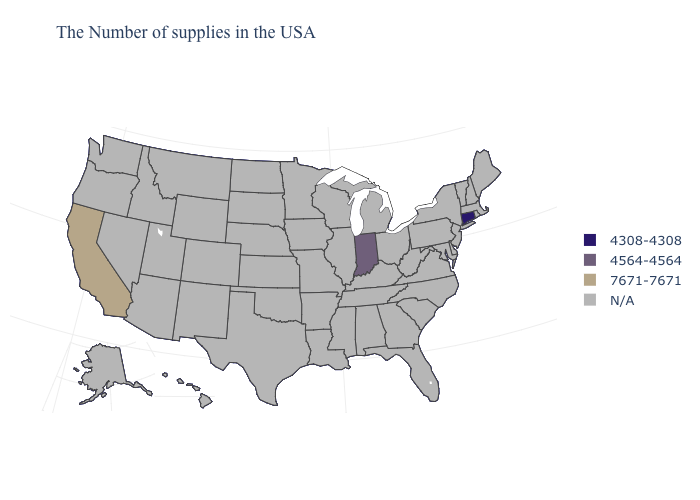Is the legend a continuous bar?
Answer briefly. No. Among the states that border Nevada , which have the lowest value?
Short answer required. California. Name the states that have a value in the range N/A?
Concise answer only. Maine, Massachusetts, Rhode Island, New Hampshire, Vermont, New York, New Jersey, Delaware, Maryland, Pennsylvania, Virginia, North Carolina, South Carolina, West Virginia, Ohio, Florida, Georgia, Michigan, Kentucky, Alabama, Tennessee, Wisconsin, Illinois, Mississippi, Louisiana, Missouri, Arkansas, Minnesota, Iowa, Kansas, Nebraska, Oklahoma, Texas, South Dakota, North Dakota, Wyoming, Colorado, New Mexico, Utah, Montana, Arizona, Idaho, Nevada, Washington, Oregon, Alaska, Hawaii. Name the states that have a value in the range 7671-7671?
Write a very short answer. California. What is the value of Alabama?
Be succinct. N/A. Name the states that have a value in the range 4564-4564?
Give a very brief answer. Indiana. Name the states that have a value in the range 4308-4308?
Be succinct. Connecticut. Name the states that have a value in the range 4564-4564?
Quick response, please. Indiana. Does the first symbol in the legend represent the smallest category?
Keep it brief. Yes. Name the states that have a value in the range 4564-4564?
Write a very short answer. Indiana. Name the states that have a value in the range 7671-7671?
Keep it brief. California. Name the states that have a value in the range 4308-4308?
Be succinct. Connecticut. 